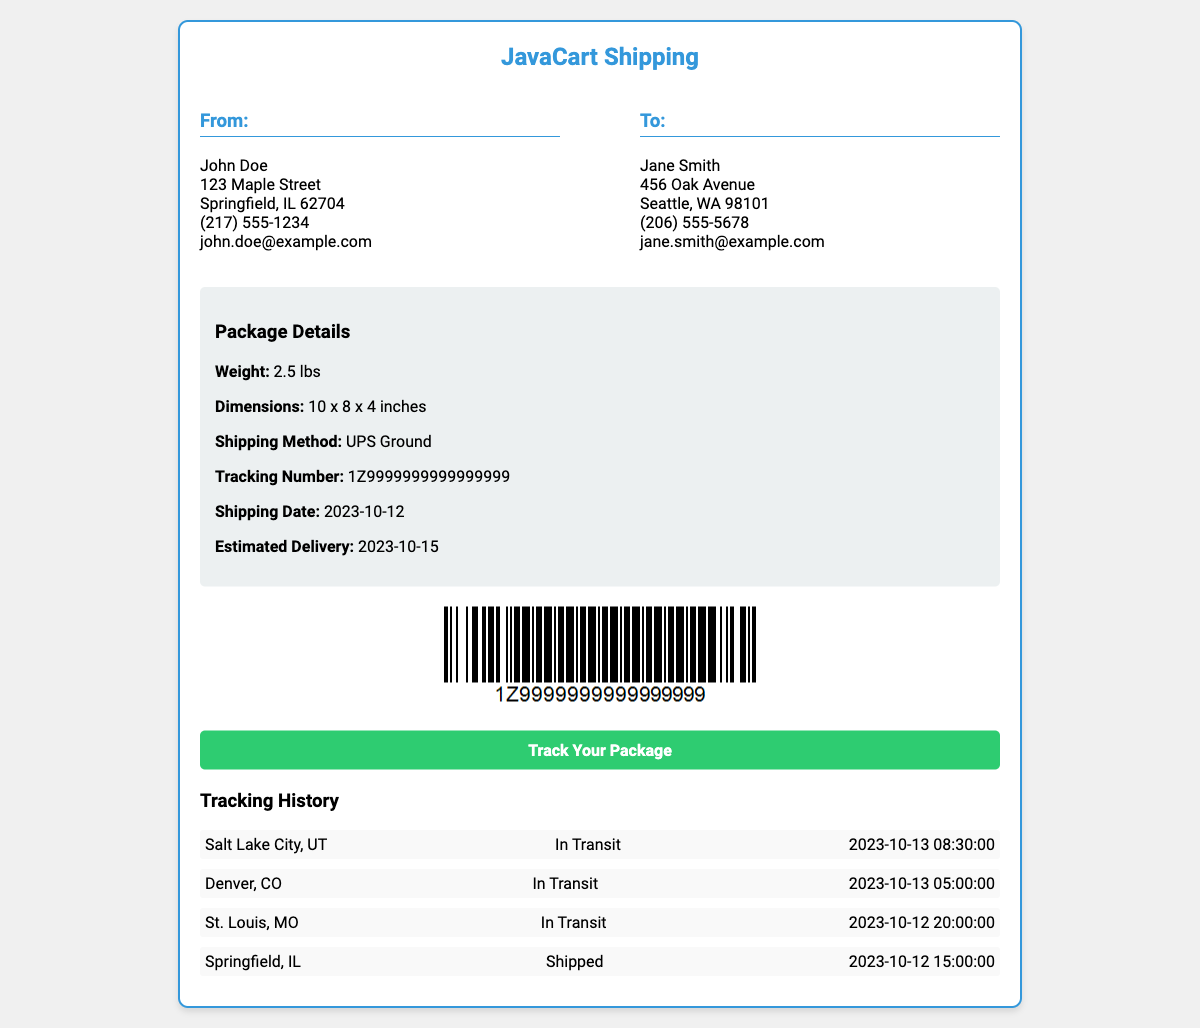What is the sender's name? The sender's name is the first name listed in the "From" section of the document.
Answer: John Doe What is the recipient's city? The recipient's city is located in the "To" section of the document and indicates where the package is being sent.
Answer: Seattle What is the weight of the package? The weight of the package is mentioned in the "Package Details" section and indicates how heavy the package is.
Answer: 2.5 lbs What is the tracking number? The tracking number is provided in the "Package Details" section and is used to track the shipment.
Answer: 1Z9999999999999999 What is the estimated delivery date? The estimated delivery date is provided in the "Package Details" section as the date the package is expected to arrive.
Answer: 2023-10-15 What shipping method is used? The shipping method is stated in the "Package Details" section, which indicates the courier service used for delivery.
Answer: UPS Ground What does the status indicate for the entry from Springfield, IL? The status indicates whether the package is currently in transit or has been shipped.
Answer: Shipped How many stops are listed in the tracking history? The number of status entries indicates the stops the package has made during transit.
Answer: 4 What color is the tracking information background? The tracking information background color helps highlight the tracking section in the document.
Answer: Green 